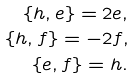<formula> <loc_0><loc_0><loc_500><loc_500>\{ h , e \} = 2 e , \\ \ \{ h , f \} = - 2 f , \\ \ \{ e , f \} = h .</formula> 